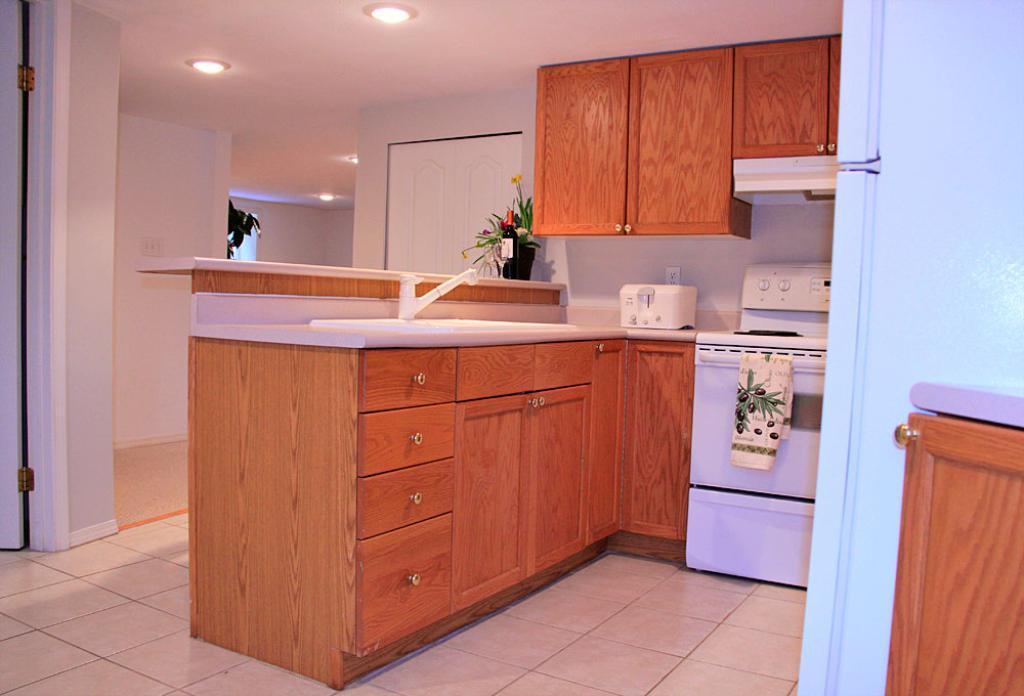How would you summarize this image in a sentence or two? In this image there is a kitchen cabinet having a sink, tap, machine, bottle, flower vase on it. Few cupboards are attached to the wall. Few lights are attached to the roof. Background there is a wall having a door. 